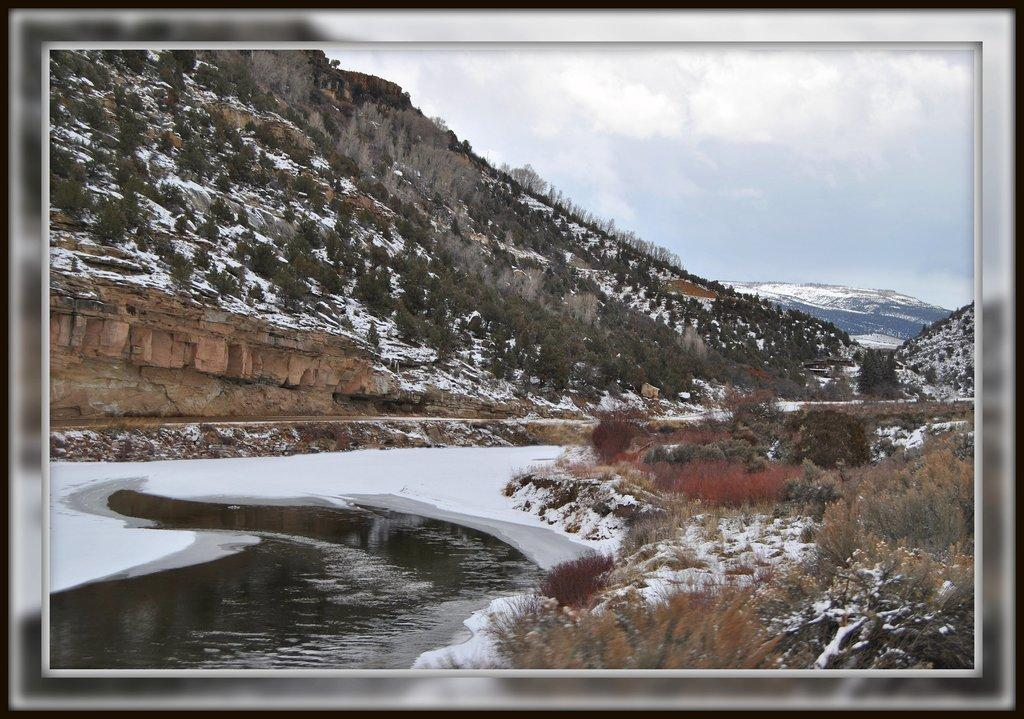What type of geographical feature is the main subject of the image? There is a mountain in the image. What can be found on the mountain? The mountain has trees and snow. What is visible at the top of the image? The sky is visible at the top of the image. What is the condition of the sky in the image? Clouds are present in the sky. What type of vegetation is present at the bottom of the image? Dry plants are present at the bottom of the image. What natural elements can be seen at the bottom of the image? There is water and snow visible at the bottom of the image. Can you see any goldfish swimming in the water at the bottom of the image? There are no goldfish present in the image; it features a mountain with snow, trees, dry plants, and water. What type of flag is flying at the top of the mountain in the image? There is no flag present in the image; it features a mountain with snow, trees, clouds, dry plants, and water. 